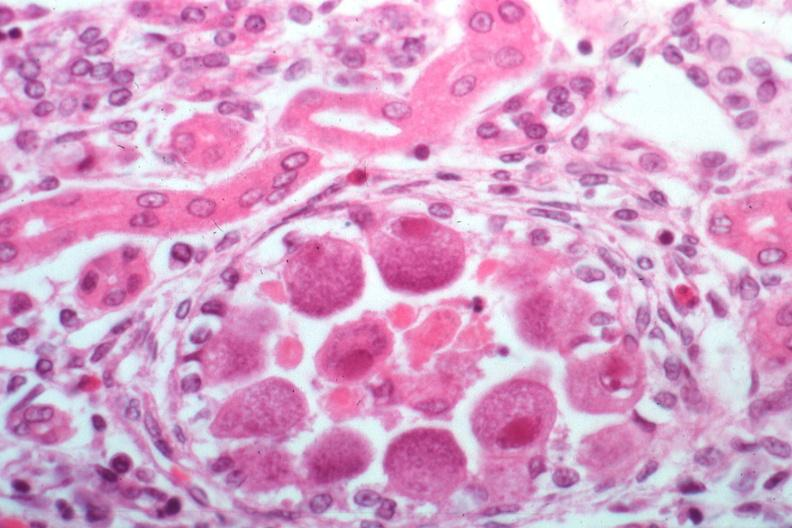what is present?
Answer the question using a single word or phrase. Kidney 